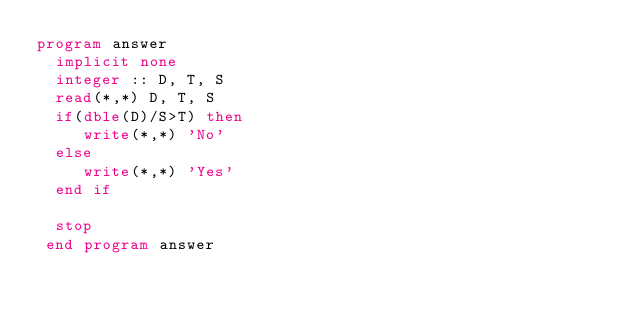<code> <loc_0><loc_0><loc_500><loc_500><_FORTRAN_>program answer
  implicit none
  integer :: D, T, S
  read(*,*) D, T, S
  if(dble(D)/S>T) then
     write(*,*) 'No'
  else
     write(*,*) 'Yes'
  end if

  stop
 end program answer</code> 